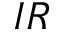<formula> <loc_0><loc_0><loc_500><loc_500>I R</formula> 